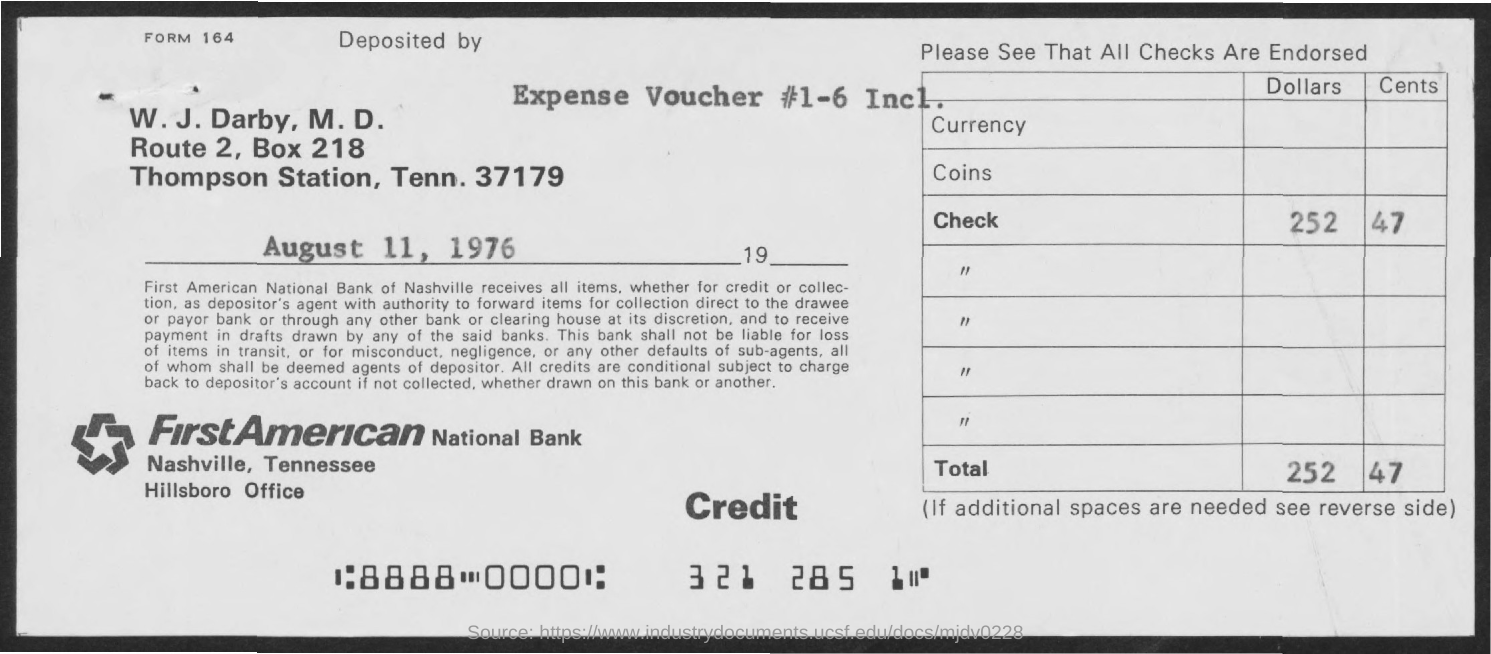Highlight a few significant elements in this photo. The question asks what the "Expense Voucher #" refers to, with possible values ranging from 1 to 6, including both numbers. FirstAmerican National Bank is the name of the bank. The BOX number is 218. 